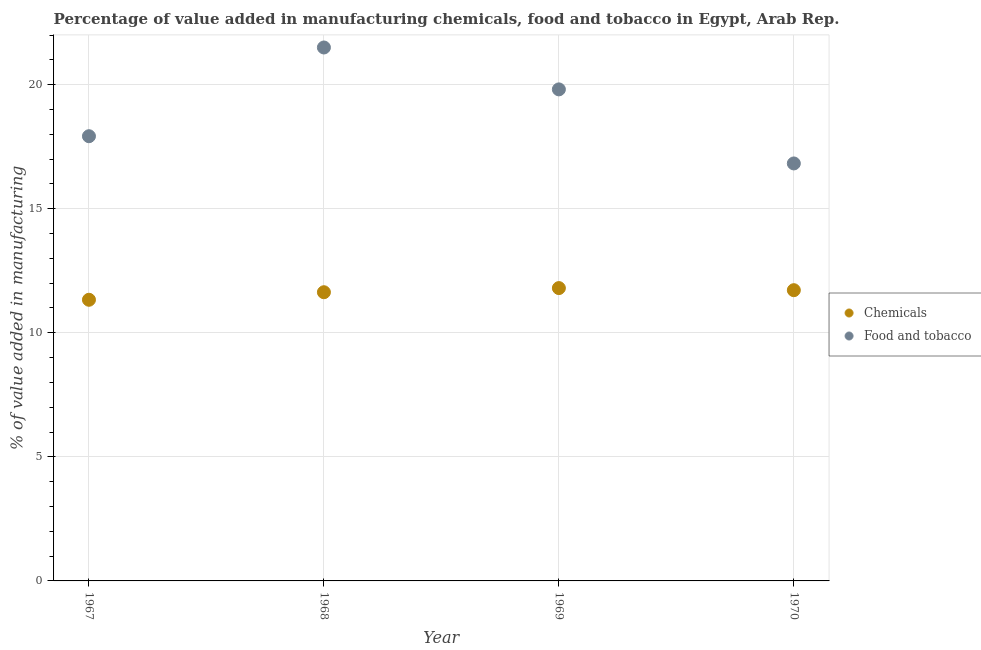Is the number of dotlines equal to the number of legend labels?
Ensure brevity in your answer.  Yes. What is the value added by  manufacturing chemicals in 1968?
Your answer should be very brief. 11.64. Across all years, what is the maximum value added by  manufacturing chemicals?
Keep it short and to the point. 11.8. Across all years, what is the minimum value added by manufacturing food and tobacco?
Provide a short and direct response. 16.83. In which year was the value added by  manufacturing chemicals maximum?
Offer a very short reply. 1969. What is the total value added by manufacturing food and tobacco in the graph?
Offer a terse response. 76.06. What is the difference between the value added by  manufacturing chemicals in 1967 and that in 1970?
Provide a succinct answer. -0.39. What is the difference between the value added by manufacturing food and tobacco in 1967 and the value added by  manufacturing chemicals in 1970?
Ensure brevity in your answer.  6.21. What is the average value added by  manufacturing chemicals per year?
Your response must be concise. 11.62. In the year 1969, what is the difference between the value added by  manufacturing chemicals and value added by manufacturing food and tobacco?
Your answer should be very brief. -8.01. What is the ratio of the value added by manufacturing food and tobacco in 1969 to that in 1970?
Your answer should be compact. 1.18. Is the value added by  manufacturing chemicals in 1968 less than that in 1969?
Offer a terse response. Yes. What is the difference between the highest and the second highest value added by  manufacturing chemicals?
Your answer should be very brief. 0.08. What is the difference between the highest and the lowest value added by  manufacturing chemicals?
Offer a terse response. 0.47. In how many years, is the value added by  manufacturing chemicals greater than the average value added by  manufacturing chemicals taken over all years?
Ensure brevity in your answer.  3. Does the value added by manufacturing food and tobacco monotonically increase over the years?
Your answer should be compact. No. How many dotlines are there?
Make the answer very short. 2. How many years are there in the graph?
Ensure brevity in your answer.  4. How many legend labels are there?
Your answer should be very brief. 2. What is the title of the graph?
Make the answer very short. Percentage of value added in manufacturing chemicals, food and tobacco in Egypt, Arab Rep. What is the label or title of the Y-axis?
Keep it short and to the point. % of value added in manufacturing. What is the % of value added in manufacturing of Chemicals in 1967?
Provide a short and direct response. 11.33. What is the % of value added in manufacturing of Food and tobacco in 1967?
Offer a terse response. 17.92. What is the % of value added in manufacturing of Chemicals in 1968?
Provide a short and direct response. 11.64. What is the % of value added in manufacturing of Food and tobacco in 1968?
Offer a very short reply. 21.5. What is the % of value added in manufacturing in Chemicals in 1969?
Make the answer very short. 11.8. What is the % of value added in manufacturing in Food and tobacco in 1969?
Your answer should be compact. 19.81. What is the % of value added in manufacturing in Chemicals in 1970?
Ensure brevity in your answer.  11.72. What is the % of value added in manufacturing in Food and tobacco in 1970?
Your answer should be very brief. 16.83. Across all years, what is the maximum % of value added in manufacturing of Chemicals?
Offer a very short reply. 11.8. Across all years, what is the maximum % of value added in manufacturing of Food and tobacco?
Provide a succinct answer. 21.5. Across all years, what is the minimum % of value added in manufacturing in Chemicals?
Give a very brief answer. 11.33. Across all years, what is the minimum % of value added in manufacturing in Food and tobacco?
Provide a short and direct response. 16.83. What is the total % of value added in manufacturing in Chemicals in the graph?
Your answer should be compact. 46.49. What is the total % of value added in manufacturing in Food and tobacco in the graph?
Offer a very short reply. 76.06. What is the difference between the % of value added in manufacturing in Chemicals in 1967 and that in 1968?
Your response must be concise. -0.3. What is the difference between the % of value added in manufacturing in Food and tobacco in 1967 and that in 1968?
Offer a very short reply. -3.58. What is the difference between the % of value added in manufacturing of Chemicals in 1967 and that in 1969?
Ensure brevity in your answer.  -0.47. What is the difference between the % of value added in manufacturing in Food and tobacco in 1967 and that in 1969?
Ensure brevity in your answer.  -1.89. What is the difference between the % of value added in manufacturing in Chemicals in 1967 and that in 1970?
Ensure brevity in your answer.  -0.39. What is the difference between the % of value added in manufacturing in Food and tobacco in 1967 and that in 1970?
Your answer should be compact. 1.1. What is the difference between the % of value added in manufacturing of Chemicals in 1968 and that in 1969?
Your answer should be very brief. -0.17. What is the difference between the % of value added in manufacturing of Food and tobacco in 1968 and that in 1969?
Ensure brevity in your answer.  1.69. What is the difference between the % of value added in manufacturing in Chemicals in 1968 and that in 1970?
Make the answer very short. -0.08. What is the difference between the % of value added in manufacturing in Food and tobacco in 1968 and that in 1970?
Your answer should be compact. 4.67. What is the difference between the % of value added in manufacturing of Chemicals in 1969 and that in 1970?
Keep it short and to the point. 0.08. What is the difference between the % of value added in manufacturing in Food and tobacco in 1969 and that in 1970?
Make the answer very short. 2.98. What is the difference between the % of value added in manufacturing in Chemicals in 1967 and the % of value added in manufacturing in Food and tobacco in 1968?
Your answer should be very brief. -10.17. What is the difference between the % of value added in manufacturing of Chemicals in 1967 and the % of value added in manufacturing of Food and tobacco in 1969?
Give a very brief answer. -8.48. What is the difference between the % of value added in manufacturing in Chemicals in 1967 and the % of value added in manufacturing in Food and tobacco in 1970?
Provide a succinct answer. -5.49. What is the difference between the % of value added in manufacturing of Chemicals in 1968 and the % of value added in manufacturing of Food and tobacco in 1969?
Your response must be concise. -8.18. What is the difference between the % of value added in manufacturing in Chemicals in 1968 and the % of value added in manufacturing in Food and tobacco in 1970?
Provide a succinct answer. -5.19. What is the difference between the % of value added in manufacturing in Chemicals in 1969 and the % of value added in manufacturing in Food and tobacco in 1970?
Make the answer very short. -5.02. What is the average % of value added in manufacturing in Chemicals per year?
Keep it short and to the point. 11.62. What is the average % of value added in manufacturing in Food and tobacco per year?
Provide a succinct answer. 19.01. In the year 1967, what is the difference between the % of value added in manufacturing in Chemicals and % of value added in manufacturing in Food and tobacco?
Make the answer very short. -6.59. In the year 1968, what is the difference between the % of value added in manufacturing in Chemicals and % of value added in manufacturing in Food and tobacco?
Provide a short and direct response. -9.86. In the year 1969, what is the difference between the % of value added in manufacturing in Chemicals and % of value added in manufacturing in Food and tobacco?
Provide a short and direct response. -8.01. In the year 1970, what is the difference between the % of value added in manufacturing in Chemicals and % of value added in manufacturing in Food and tobacco?
Provide a succinct answer. -5.11. What is the ratio of the % of value added in manufacturing of Chemicals in 1967 to that in 1968?
Your answer should be very brief. 0.97. What is the ratio of the % of value added in manufacturing in Food and tobacco in 1967 to that in 1968?
Give a very brief answer. 0.83. What is the ratio of the % of value added in manufacturing of Chemicals in 1967 to that in 1969?
Keep it short and to the point. 0.96. What is the ratio of the % of value added in manufacturing in Food and tobacco in 1967 to that in 1969?
Your answer should be compact. 0.9. What is the ratio of the % of value added in manufacturing of Food and tobacco in 1967 to that in 1970?
Offer a terse response. 1.07. What is the ratio of the % of value added in manufacturing of Chemicals in 1968 to that in 1969?
Keep it short and to the point. 0.99. What is the ratio of the % of value added in manufacturing in Food and tobacco in 1968 to that in 1969?
Keep it short and to the point. 1.09. What is the ratio of the % of value added in manufacturing of Food and tobacco in 1968 to that in 1970?
Ensure brevity in your answer.  1.28. What is the ratio of the % of value added in manufacturing in Food and tobacco in 1969 to that in 1970?
Provide a succinct answer. 1.18. What is the difference between the highest and the second highest % of value added in manufacturing in Chemicals?
Give a very brief answer. 0.08. What is the difference between the highest and the second highest % of value added in manufacturing of Food and tobacco?
Your response must be concise. 1.69. What is the difference between the highest and the lowest % of value added in manufacturing of Chemicals?
Give a very brief answer. 0.47. What is the difference between the highest and the lowest % of value added in manufacturing in Food and tobacco?
Offer a very short reply. 4.67. 